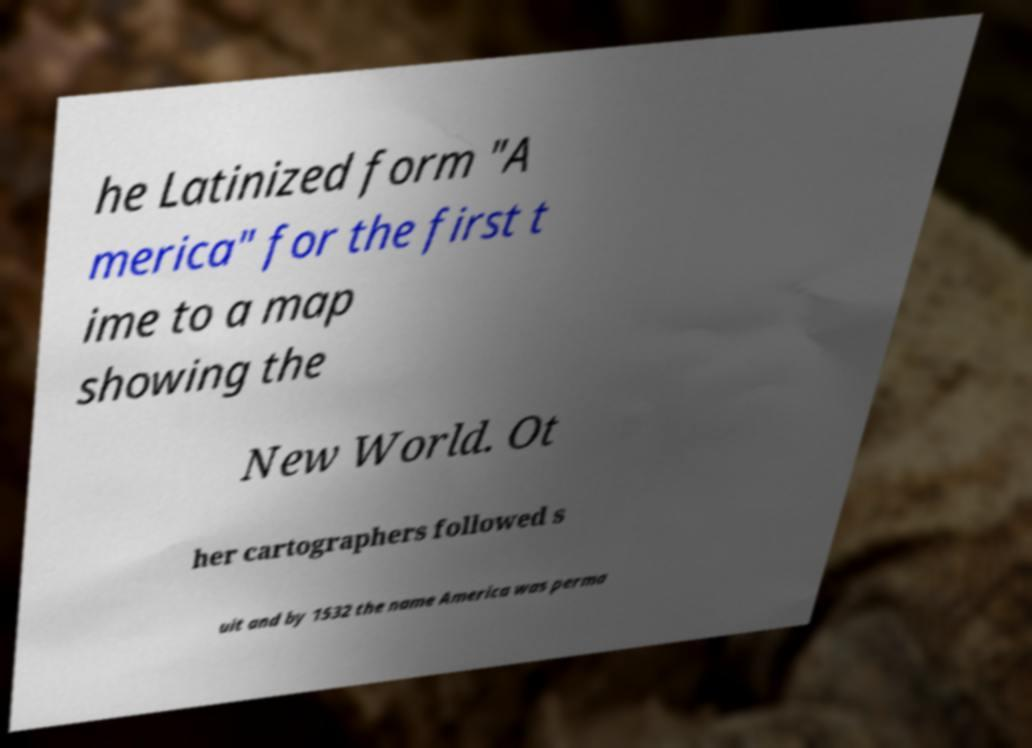Could you assist in decoding the text presented in this image and type it out clearly? he Latinized form "A merica" for the first t ime to a map showing the New World. Ot her cartographers followed s uit and by 1532 the name America was perma 